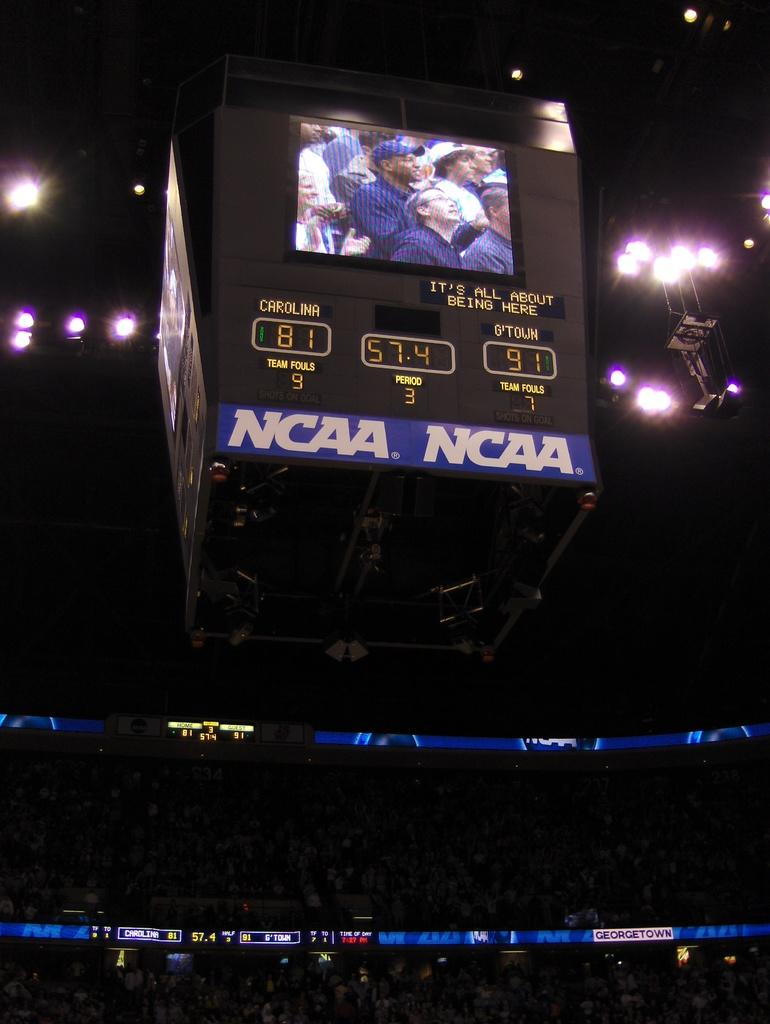Provide a one-sentence caption for the provided image. G'town is raking the lead against Carolina in the NCAA championship. 